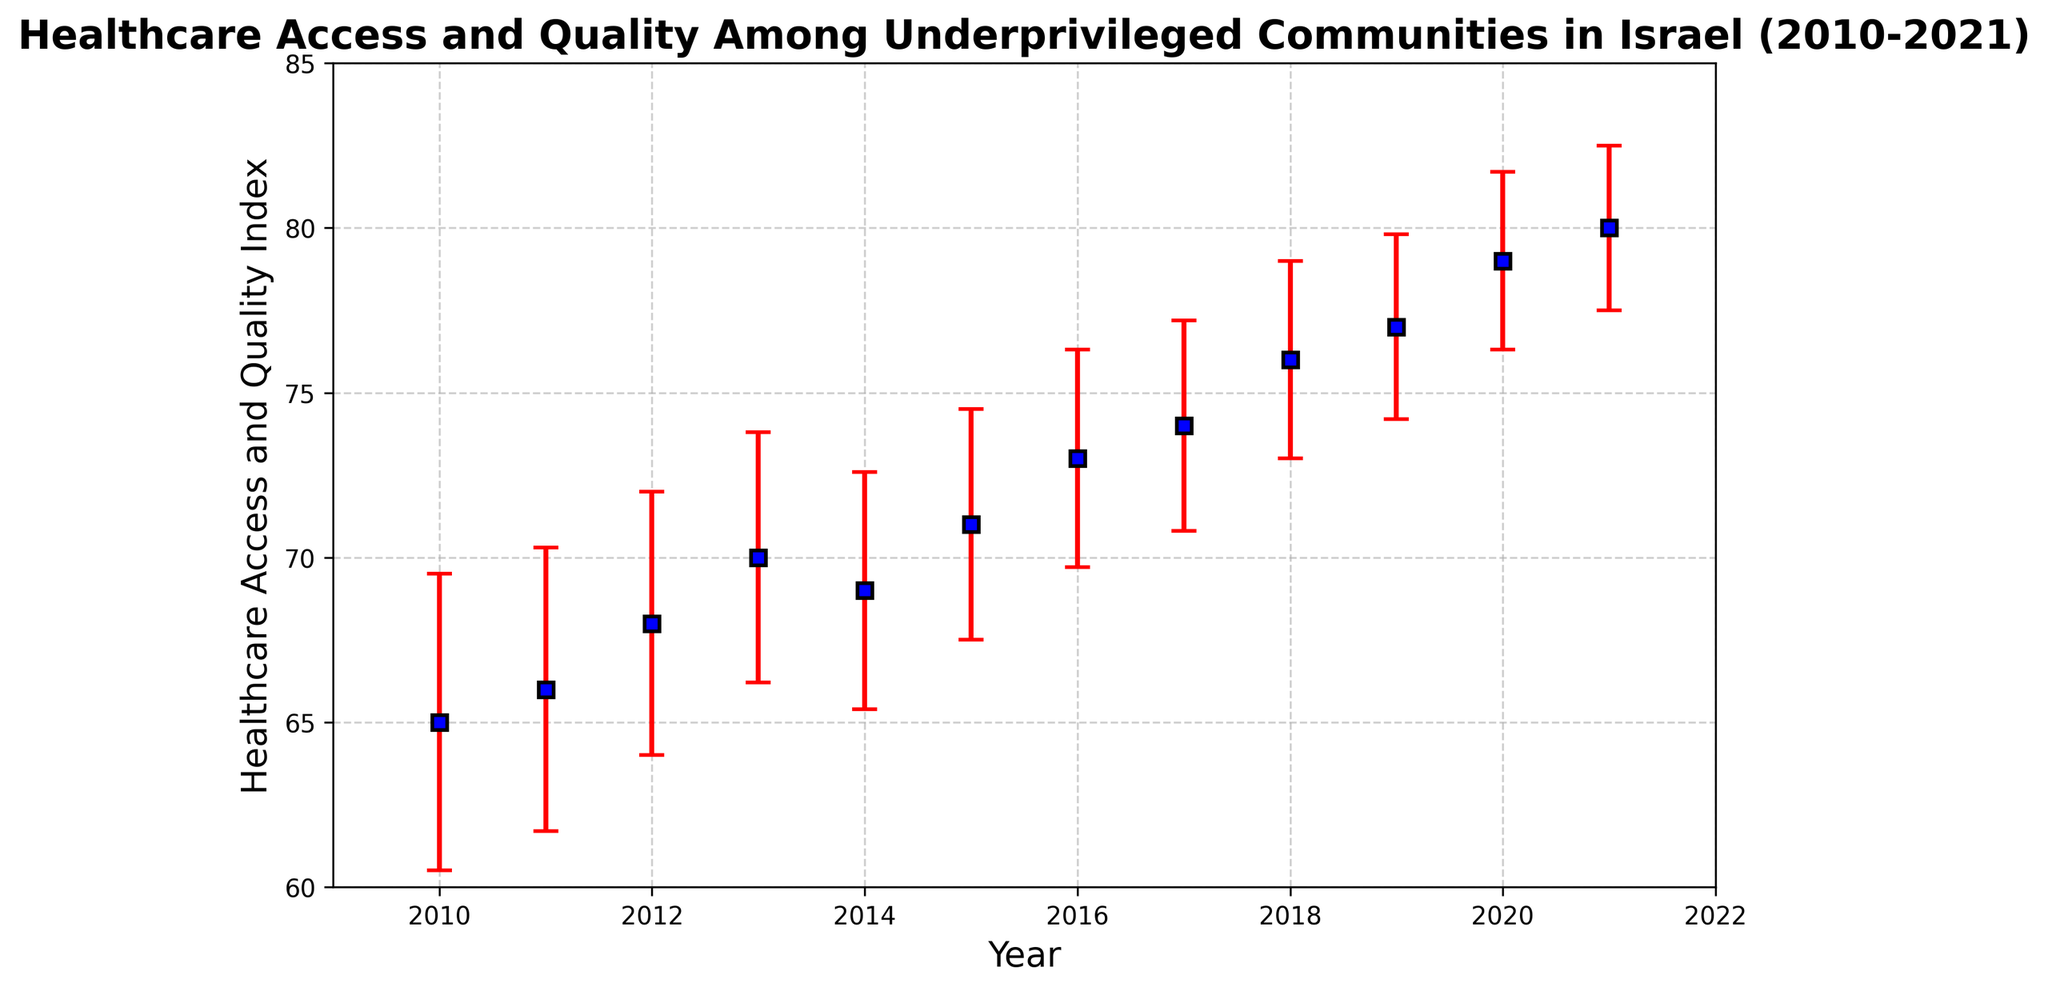What is the index value for Healthcare Access and Quality in 2015? Locate the point corresponding to the year 2015 on the x-axis and read the Healthcare Access and Quality value from the y-axis. The index value for 2015 is 71.
Answer: 71 How much did the Healthcare Access and Quality index improve from 2010 to 2021? Subtract the 2010 value from the 2021 value (80 - 65 = 15) to determine the improvement over this period.
Answer: 15 In which year did the Healthcare Access and Quality index reach 74? Find the point on the y-axis at 74 and then trace to the corresponding year on the x-axis. The year is 2017.
Answer: 2017 Which year shows the smallest error margin? Compare the error bars for each year and identify the smallest one. The smallest error margin is 2.5 in 2021.
Answer: 2021 Did the Healthcare Access and Quality index ever decrease from one year to the next? Look at the trend line and identify any downward slopes. The index decreased from 2013 (70) to 2014 (69).
Answer: Yes, from 2013 to 2014 What is the average Healthcare Access and Quality index between 2010 and 2015? Add up the values from 2010 to 2015 (65 + 66 + 68 + 70 + 69 + 71 = 409) and divide by the number of years (6). The average is 409 / 6 ≈ 68.17.
Answer: 68.17 How does the error margin in 2020 compare to the error margin in 2011? Compare the error bar values: 2.7 in 2020 and 4.3 in 2011. The error margin in 2020 is smaller.
Answer: 2020 has a smaller error margin Between which consecutive years was the biggest increase in Healthcare Access and Quality index observed? Calculate the differences between consecutive years and find the largest difference: 2021-2020 (80-79 = 1), 2020-2019 (79-77 = 2), 2019-2018 (77-76 = 1), ... The biggest increase is from 2018 to 2019 (2 units).
Answer: 2018 to 2019 Which year had the highest Healthcare Access and Quality index, and what was the value? Look for the highest point on the y-axis and identify the corresponding year on the x-axis. The highest index is 80 in 2021.
Answer: 80 in 2021 